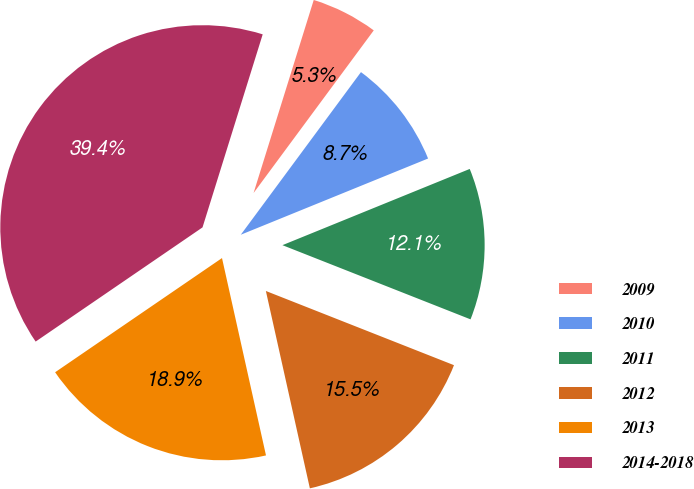Convert chart to OTSL. <chart><loc_0><loc_0><loc_500><loc_500><pie_chart><fcel>2009<fcel>2010<fcel>2011<fcel>2012<fcel>2013<fcel>2014-2018<nl><fcel>5.32%<fcel>8.72%<fcel>12.13%<fcel>15.53%<fcel>18.94%<fcel>39.36%<nl></chart> 